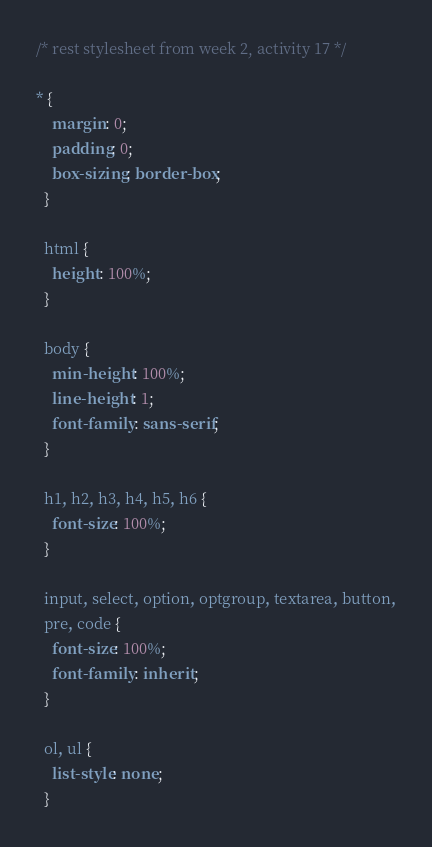Convert code to text. <code><loc_0><loc_0><loc_500><loc_500><_CSS_>/* rest stylesheet from week 2, activity 17 */

* {
    margin: 0;
    padding: 0;
    box-sizing: border-box;
  }
  
  html {
    height: 100%;
  }
  
  body {
    min-height: 100%;
    line-height: 1;
    font-family: sans-serif;
  }
  
  h1, h2, h3, h4, h5, h6 {
    font-size: 100%;
  }
  
  input, select, option, optgroup, textarea, button,
  pre, code {
    font-size: 100%;
    font-family: inherit;
  }
  
  ol, ul {
    list-style: none;
  }</code> 